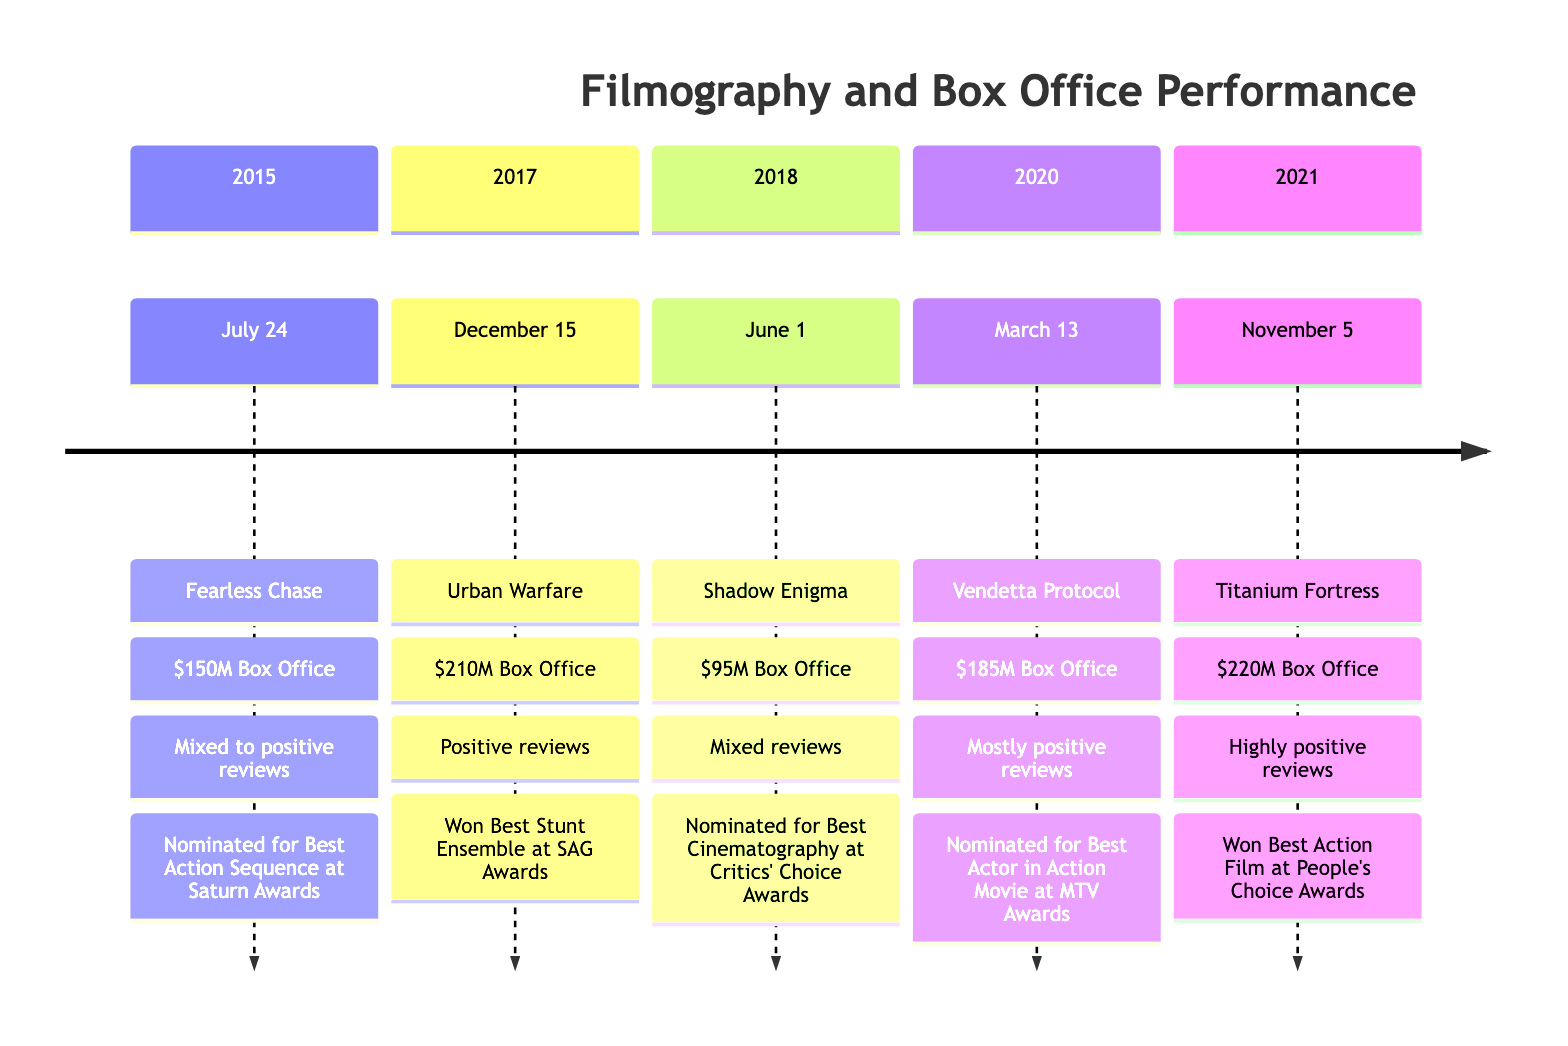What is the box office performance of "Urban Warfare"? The diagram specifies that "Urban Warfare," released on December 15, 2017, has a box office performance of 210 million USD.
Answer: 210 million USD What award did "Titanium Fortress" win? According to the diagram, "Titanium Fortress" won Best Action Film at the People's Choice Awards, and this information is directly stated under its entry for November 5, 2021.
Answer: Best Action Film at the People's Choice Awards Which film received mixed to positive reviews? From the diagram, "Fearless Chase," released on July 24, 2015, is noted for receiving mixed to positive reviews, which is directly stated under its corresponding section.
Answer: Fearless Chase What is the release date of "Shadow Enigma"? The diagram shows that "Shadow Enigma" was released on June 1, 2018, and this is clearly listed in its timeline section.
Answer: June 1, 2018 Which film had the highest box office collection? By reviewing the box office figures presented in the timeline, "Titanium Fortress" with 220 million USD has the highest box office, as it is the maximum value visible among the listed films.
Answer: 220 million USD How many films were released between 2015 and 2021? The diagram lists a total of five films released during the specified period: "Fearless Chase," "Urban Warfare," "Shadow Enigma," "Vendetta Protocol," and "Titanium Fortress." Therefore, the total count is five films.
Answer: 5 Which film was nominated for Best Action Sequence? The timeline indicates that "Fearless Chase" was nominated for Best Action Sequence at the Saturn Awards, noted under the film's release entry date.
Answer: Fearless Chase What overall trend can be seen in the box office performances of the films from 2015 to 2021? Upon examining the box office performance of each film in chronological order, it shows a general trend of increasing box office collection, with each successive film generally having a higher box office than its predecessor.
Answer: Increasing trend What kind of critical reception did "Vendetta Protocol" receive? The diagram indicates that "Vendetta Protocol," released on March 13, 2020, received mostly positive reviews, as stated in its entry under the timeline.
Answer: Mostly positive reviews 